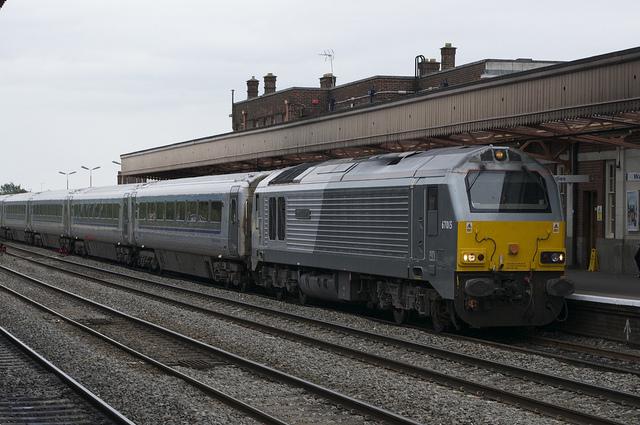Is the train in station?
Keep it brief. Yes. What colors is the train on the right?
Write a very short answer. Silver and yellow. How many train cars can be seen?
Quick response, please. 5. What is the man riding?
Be succinct. Train. What is the color of the train?
Write a very short answer. Silver and yellow. Is this a modern train?
Be succinct. Yes. Is the train moving?
Keep it brief. No. How many train tracks are visible?
Short answer required. 4. What type of moving vehicle is seen?
Concise answer only. Train. What is above the train?
Concise answer only. Roof. How many trucks of rail are there?
Give a very brief answer. 4. How many  Railroad  are there?
Short answer required. 4. How many different trains are on the tracks?
Keep it brief. 1. What color is the front of the engine?
Write a very short answer. Yellow. What color is the train?
Answer briefly. Gray. Are the buildings abandoned?
Short answer required. No. Is this train in the station?
Short answer required. Yes. How many sets of tracks are there?
Short answer required. 4. Is this a black and white photo?
Write a very short answer. No. Where is the train station?
Answer briefly. Outside. How many train tracks do you see?
Give a very brief answer. 4. What color are the doors on the train?
Concise answer only. Silver. How many trains are there in the picture?
Quick response, please. 1. Is the train very long?
Keep it brief. Yes. IS there clouds in the sky?
Keep it brief. Yes. How many cars are there?
Concise answer only. 5. 